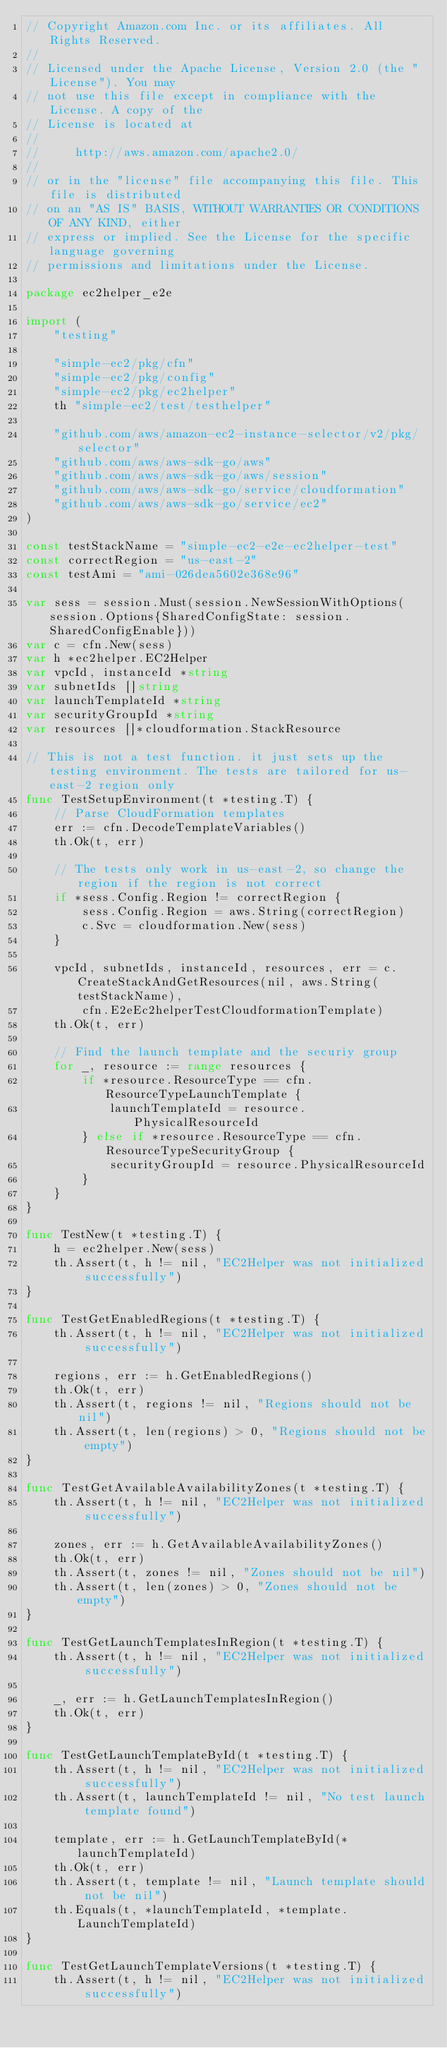Convert code to text. <code><loc_0><loc_0><loc_500><loc_500><_Go_>// Copyright Amazon.com Inc. or its affiliates. All Rights Reserved.
//
// Licensed under the Apache License, Version 2.0 (the "License"). You may
// not use this file except in compliance with the License. A copy of the
// License is located at
//
//     http://aws.amazon.com/apache2.0/
//
// or in the "license" file accompanying this file. This file is distributed
// on an "AS IS" BASIS, WITHOUT WARRANTIES OR CONDITIONS OF ANY KIND, either
// express or implied. See the License for the specific language governing
// permissions and limitations under the License.

package ec2helper_e2e

import (
	"testing"

	"simple-ec2/pkg/cfn"
	"simple-ec2/pkg/config"
	"simple-ec2/pkg/ec2helper"
	th "simple-ec2/test/testhelper"

	"github.com/aws/amazon-ec2-instance-selector/v2/pkg/selector"
	"github.com/aws/aws-sdk-go/aws"
	"github.com/aws/aws-sdk-go/aws/session"
	"github.com/aws/aws-sdk-go/service/cloudformation"
	"github.com/aws/aws-sdk-go/service/ec2"
)

const testStackName = "simple-ec2-e2e-ec2helper-test"
const correctRegion = "us-east-2"
const testAmi = "ami-026dea5602e368e96"

var sess = session.Must(session.NewSessionWithOptions(session.Options{SharedConfigState: session.SharedConfigEnable}))
var c = cfn.New(sess)
var h *ec2helper.EC2Helper
var vpcId, instanceId *string
var subnetIds []string
var launchTemplateId *string
var securityGroupId *string
var resources []*cloudformation.StackResource

// This is not a test function. it just sets up the testing environment. The tests are tailored for us-east-2 region only
func TestSetupEnvironment(t *testing.T) {
	// Parse CloudFormation templates
	err := cfn.DecodeTemplateVariables()
	th.Ok(t, err)

	// The tests only work in us-east-2, so change the region if the region is not correct
	if *sess.Config.Region != correctRegion {
		sess.Config.Region = aws.String(correctRegion)
		c.Svc = cloudformation.New(sess)
	}

	vpcId, subnetIds, instanceId, resources, err = c.CreateStackAndGetResources(nil, aws.String(testStackName),
		cfn.E2eEc2helperTestCloudformationTemplate)
	th.Ok(t, err)

	// Find the launch template and the securiy group
	for _, resource := range resources {
		if *resource.ResourceType == cfn.ResourceTypeLaunchTemplate {
			launchTemplateId = resource.PhysicalResourceId
		} else if *resource.ResourceType == cfn.ResourceTypeSecurityGroup {
			securityGroupId = resource.PhysicalResourceId
		}
	}
}

func TestNew(t *testing.T) {
	h = ec2helper.New(sess)
	th.Assert(t, h != nil, "EC2Helper was not initialized successfully")
}

func TestGetEnabledRegions(t *testing.T) {
	th.Assert(t, h != nil, "EC2Helper was not initialized successfully")

	regions, err := h.GetEnabledRegions()
	th.Ok(t, err)
	th.Assert(t, regions != nil, "Regions should not be nil")
	th.Assert(t, len(regions) > 0, "Regions should not be empty")
}

func TestGetAvailableAvailabilityZones(t *testing.T) {
	th.Assert(t, h != nil, "EC2Helper was not initialized successfully")

	zones, err := h.GetAvailableAvailabilityZones()
	th.Ok(t, err)
	th.Assert(t, zones != nil, "Zones should not be nil")
	th.Assert(t, len(zones) > 0, "Zones should not be empty")
}

func TestGetLaunchTemplatesInRegion(t *testing.T) {
	th.Assert(t, h != nil, "EC2Helper was not initialized successfully")

	_, err := h.GetLaunchTemplatesInRegion()
	th.Ok(t, err)
}

func TestGetLaunchTemplateById(t *testing.T) {
	th.Assert(t, h != nil, "EC2Helper was not initialized successfully")
	th.Assert(t, launchTemplateId != nil, "No test launch template found")

	template, err := h.GetLaunchTemplateById(*launchTemplateId)
	th.Ok(t, err)
	th.Assert(t, template != nil, "Launch template should not be nil")
	th.Equals(t, *launchTemplateId, *template.LaunchTemplateId)
}

func TestGetLaunchTemplateVersions(t *testing.T) {
	th.Assert(t, h != nil, "EC2Helper was not initialized successfully")</code> 